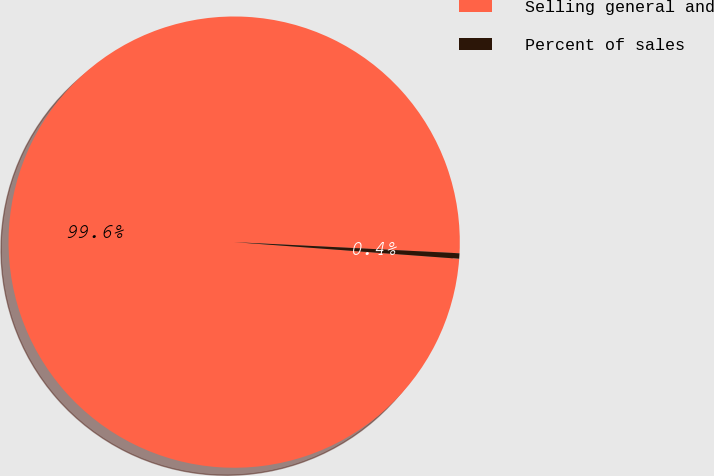<chart> <loc_0><loc_0><loc_500><loc_500><pie_chart><fcel>Selling general and<fcel>Percent of sales<nl><fcel>99.61%<fcel>0.39%<nl></chart> 